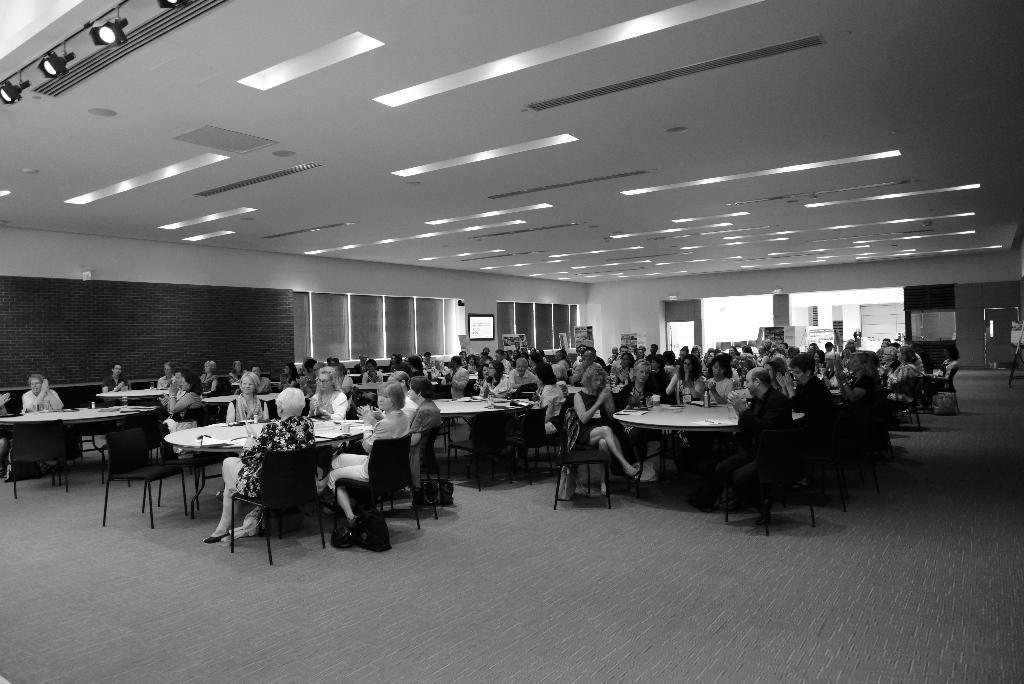What is the color scheme of the image? The image is black and white. How many people are in the image? There are many persons in the image. What are the persons doing in the image? The persons are sitting on chairs at tables. What can be seen in the background of the image? There are windows, lights, doors, screens, and a wall in the background of the image. What type of plants are hanging from the frame in the image? There is no frame or plants present in the image. Who is the manager of the group in the image? There is no indication of a group or a manager in the image. 